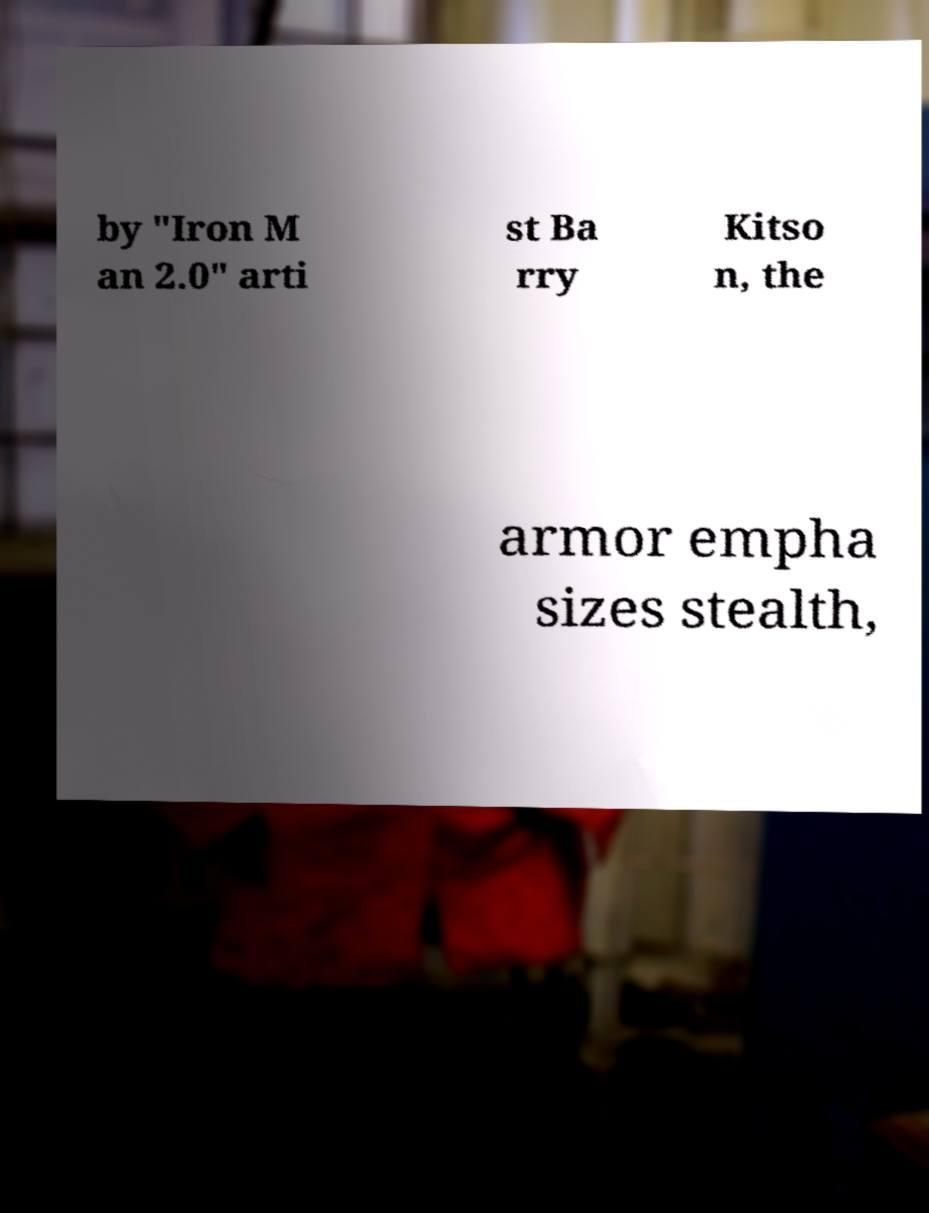Can you read and provide the text displayed in the image?This photo seems to have some interesting text. Can you extract and type it out for me? by "Iron M an 2.0" arti st Ba rry Kitso n, the armor empha sizes stealth, 